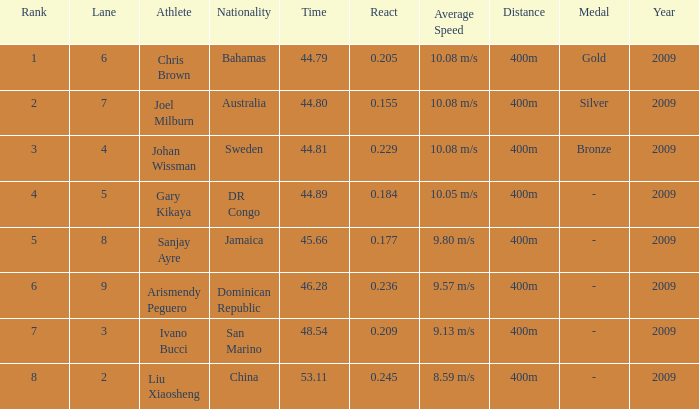What's the average value of ranks for competitors who have a lane number below 4 and are from san marino? 7.0. 